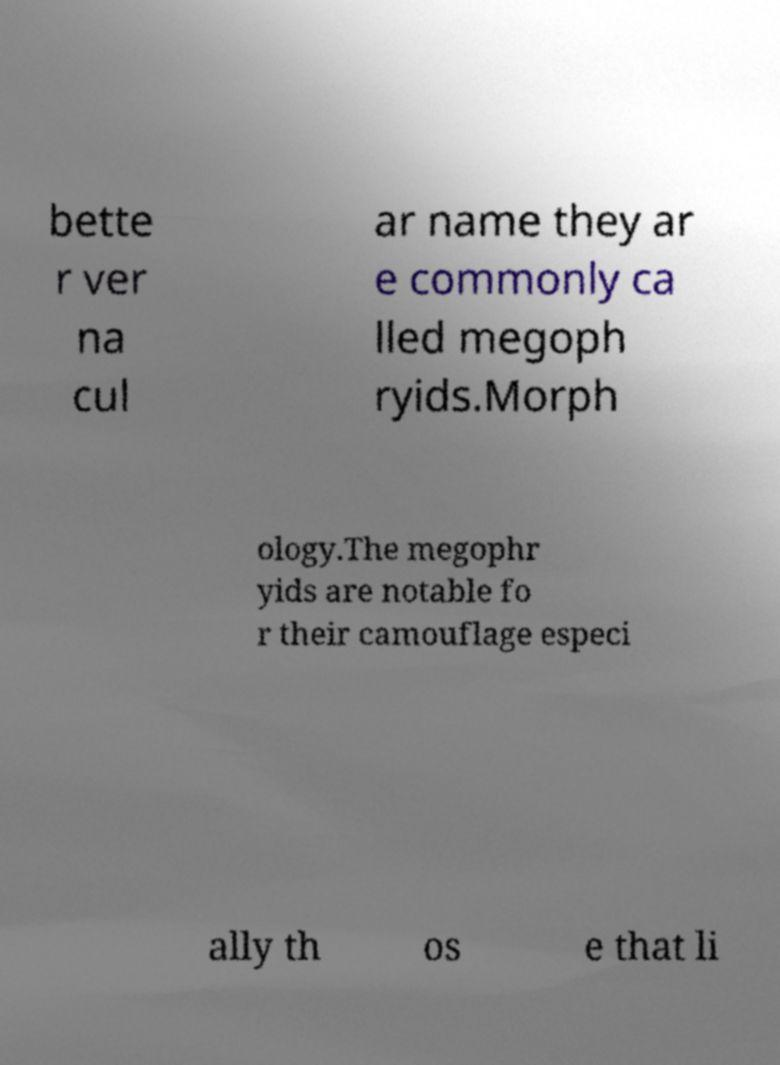Can you accurately transcribe the text from the provided image for me? bette r ver na cul ar name they ar e commonly ca lled megoph ryids.Morph ology.The megophr yids are notable fo r their camouflage especi ally th os e that li 